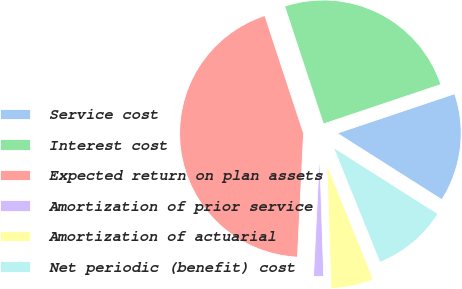Convert chart to OTSL. <chart><loc_0><loc_0><loc_500><loc_500><pie_chart><fcel>Service cost<fcel>Interest cost<fcel>Expected return on plan assets<fcel>Amortization of prior service<fcel>Amortization of actuarial<fcel>Net periodic (benefit) cost<nl><fcel>14.16%<fcel>24.9%<fcel>44.15%<fcel>1.31%<fcel>5.59%<fcel>9.88%<nl></chart> 